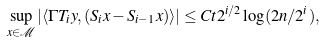Convert formula to latex. <formula><loc_0><loc_0><loc_500><loc_500>\sup _ { x \in \mathcal { M } } | \langle \Gamma T _ { i } y , ( S _ { i } x - S _ { i - 1 } x ) \rangle | \leq C t 2 ^ { i / 2 } \log ( 2 n / 2 ^ { i } ) ,</formula> 